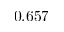Convert formula to latex. <formula><loc_0><loc_0><loc_500><loc_500>0 . 6 5 7</formula> 